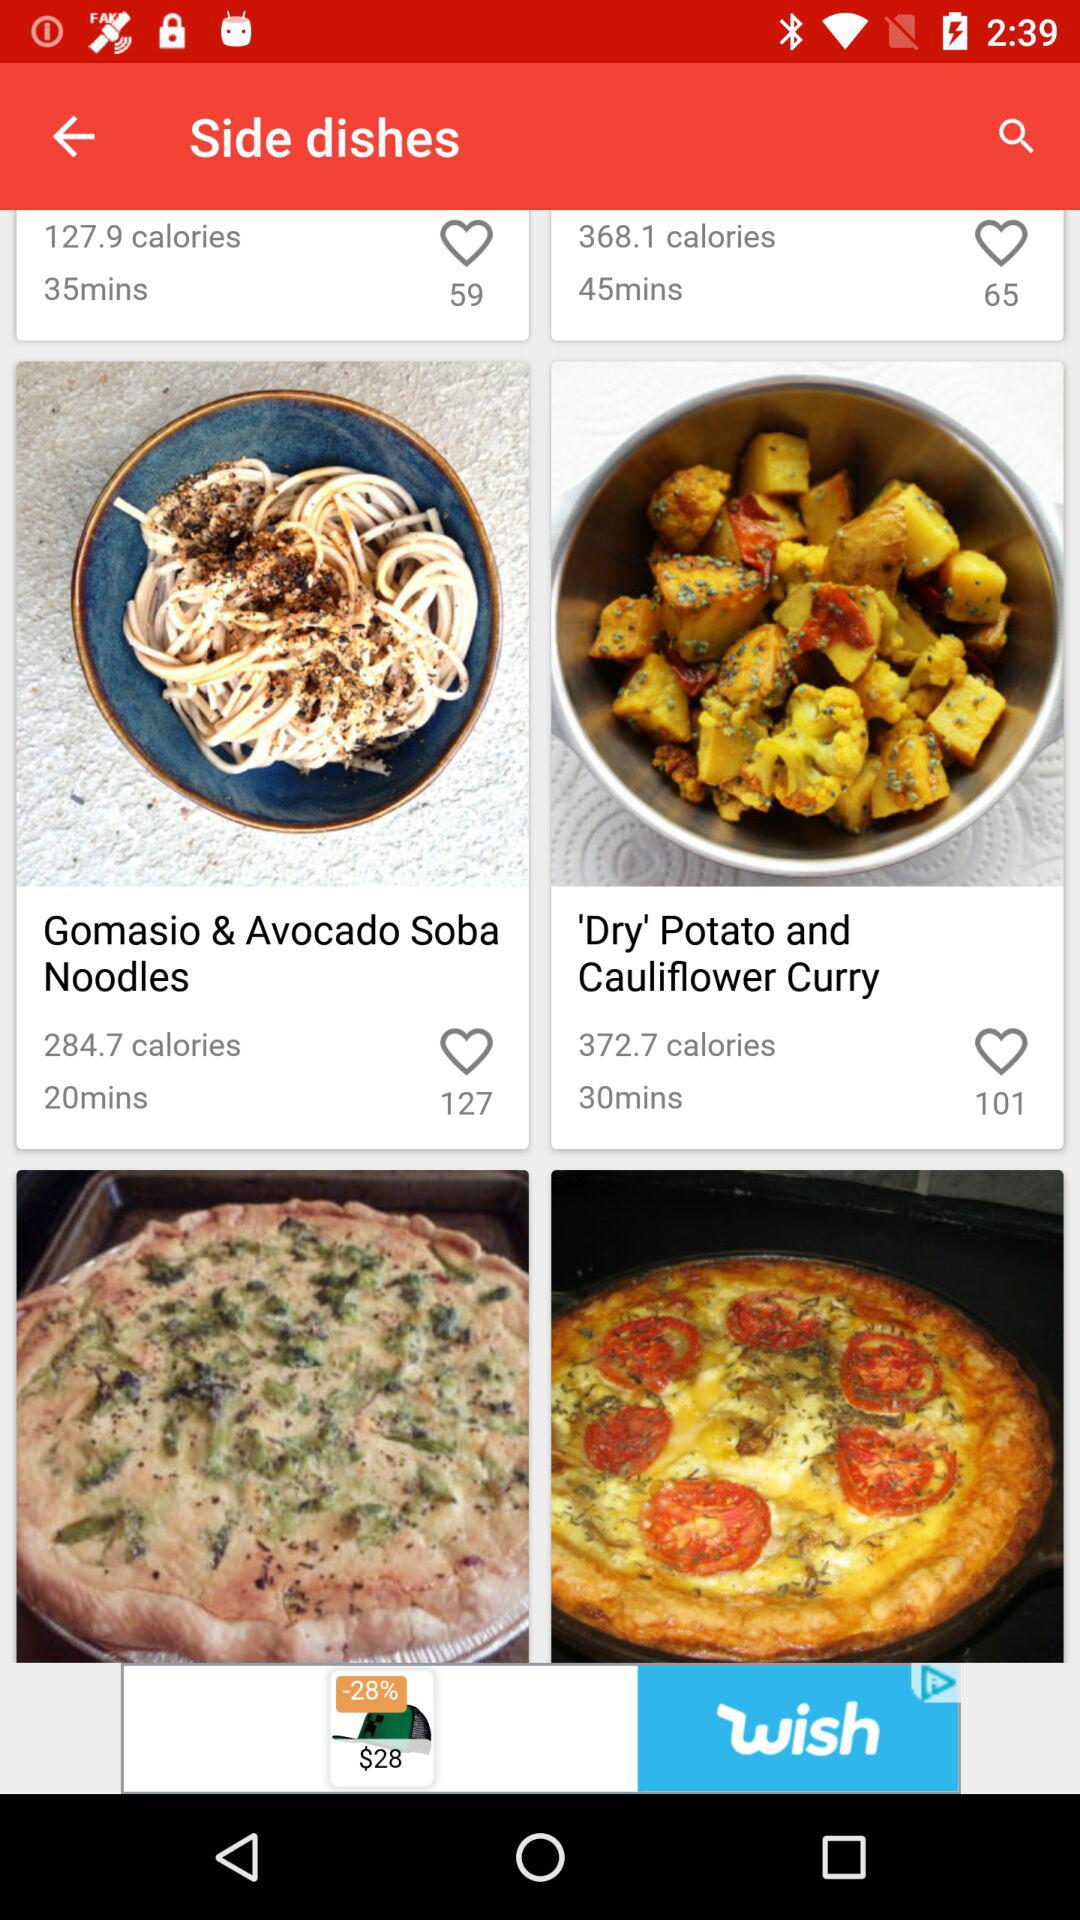How many items have a calorie count under 300?
Answer the question using a single word or phrase. 2 